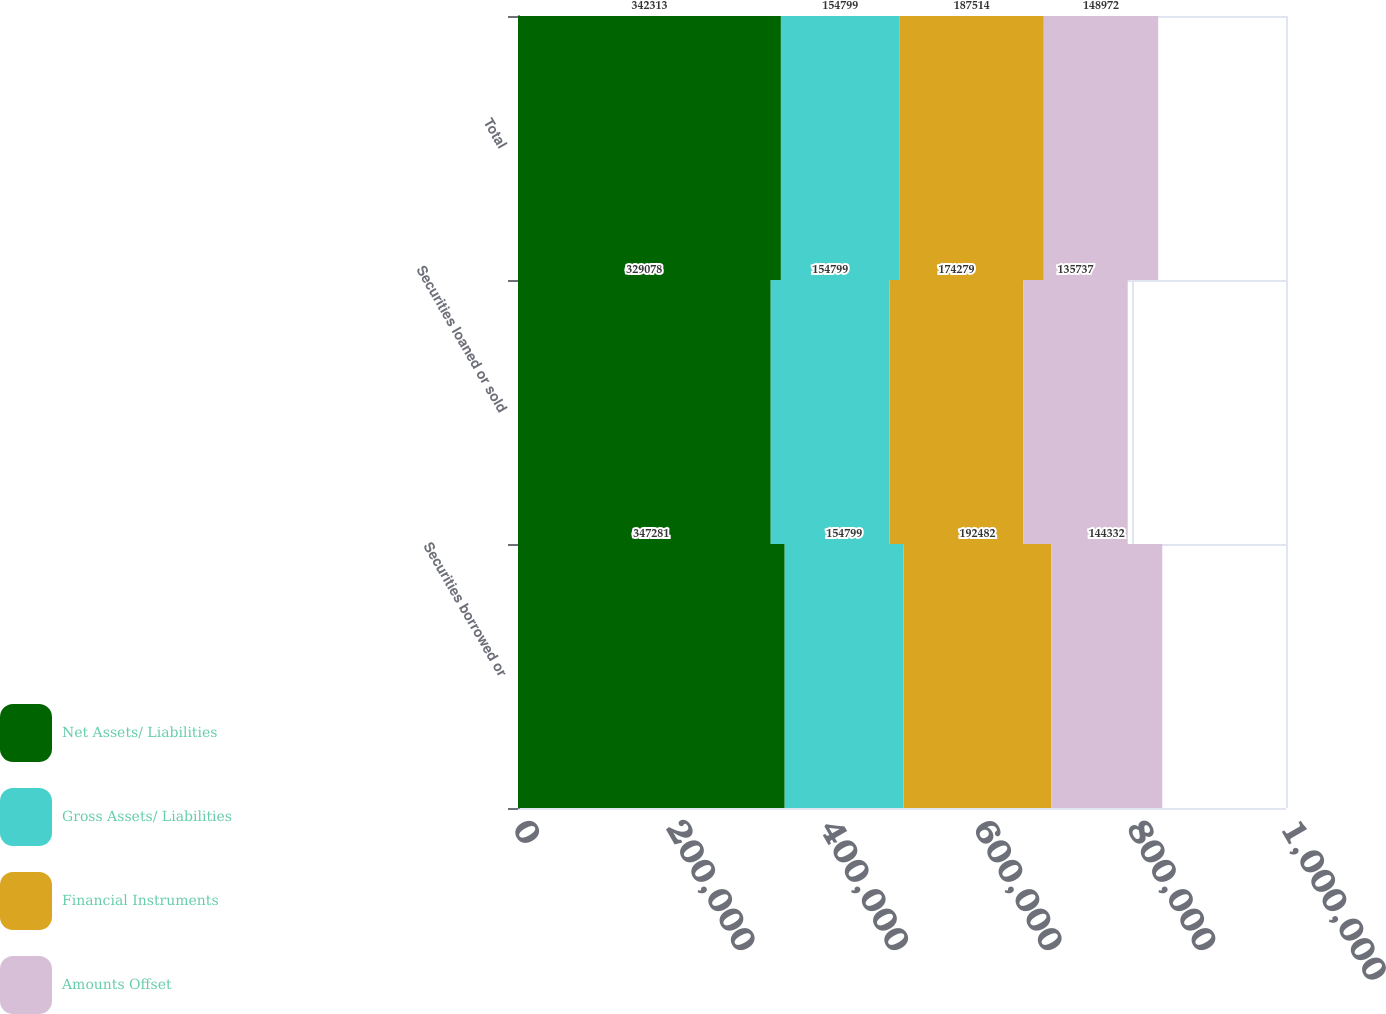<chart> <loc_0><loc_0><loc_500><loc_500><stacked_bar_chart><ecel><fcel>Securities borrowed or<fcel>Securities loaned or sold<fcel>Total<nl><fcel>Net Assets/ Liabilities<fcel>347281<fcel>329078<fcel>342313<nl><fcel>Gross Assets/ Liabilities<fcel>154799<fcel>154799<fcel>154799<nl><fcel>Financial Instruments<fcel>192482<fcel>174279<fcel>187514<nl><fcel>Amounts Offset<fcel>144332<fcel>135737<fcel>148972<nl></chart> 